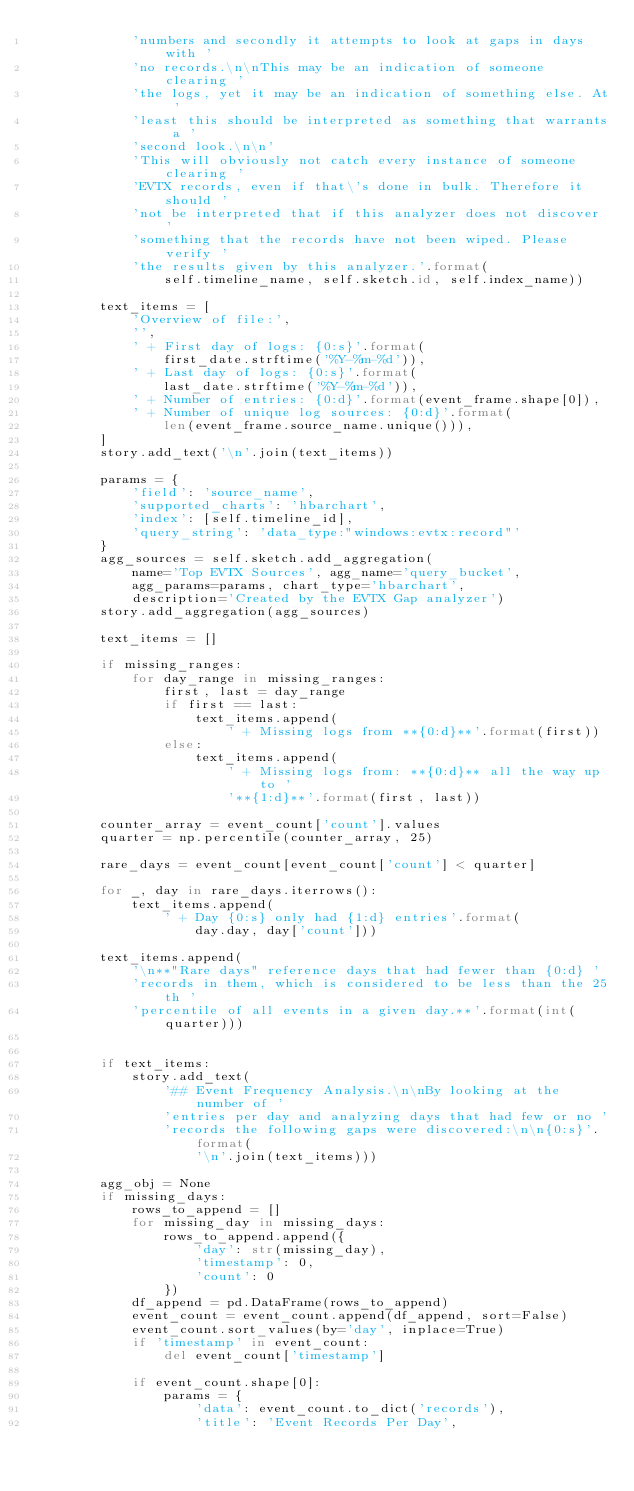Convert code to text. <code><loc_0><loc_0><loc_500><loc_500><_Python_>            'numbers and secondly it attempts to look at gaps in days with '
            'no records.\n\nThis may be an indication of someone clearing '
            'the logs, yet it may be an indication of something else. At '
            'least this should be interpreted as something that warrants a '
            'second look.\n\n'
            'This will obviously not catch every instance of someone clearing '
            'EVTX records, even if that\'s done in bulk. Therefore it should '
            'not be interpreted that if this analyzer does not discover '
            'something that the records have not been wiped. Please verify '
            'the results given by this analyzer.'.format(
                self.timeline_name, self.sketch.id, self.index_name))

        text_items = [
            'Overview of file:',
            '',
            ' + First day of logs: {0:s}'.format(
                first_date.strftime('%Y-%m-%d')),
            ' + Last day of logs: {0:s}'.format(
                last_date.strftime('%Y-%m-%d')),
            ' + Number of entries: {0:d}'.format(event_frame.shape[0]),
            ' + Number of unique log sources: {0:d}'.format(
                len(event_frame.source_name.unique())),
        ]
        story.add_text('\n'.join(text_items))

        params = {
            'field': 'source_name',
            'supported_charts': 'hbarchart',
            'index': [self.timeline_id],
            'query_string': 'data_type:"windows:evtx:record"'
        }
        agg_sources = self.sketch.add_aggregation(
            name='Top EVTX Sources', agg_name='query_bucket',
            agg_params=params, chart_type='hbarchart',
            description='Created by the EVTX Gap analyzer')
        story.add_aggregation(agg_sources)

        text_items = []

        if missing_ranges:
            for day_range in missing_ranges:
                first, last = day_range
                if first == last:
                    text_items.append(
                        ' + Missing logs from **{0:d}**'.format(first))
                else:
                    text_items.append(
                        ' + Missing logs from: **{0:d}** all the way up to '
                        '**{1:d}**'.format(first, last))

        counter_array = event_count['count'].values
        quarter = np.percentile(counter_array, 25)

        rare_days = event_count[event_count['count'] < quarter]

        for _, day in rare_days.iterrows():
            text_items.append(
                ' + Day {0:s} only had {1:d} entries'.format(
                    day.day, day['count']))

        text_items.append(
            '\n**"Rare days" reference days that had fewer than {0:d} '
            'records in them, which is considered to be less than the 25th '
            'percentile of all events in a given day.**'.format(int(quarter)))


        if text_items:
            story.add_text(
                '## Event Frequency Analysis.\n\nBy looking at the number of '
                'entries per day and analyzing days that had few or no '
                'records the following gaps were discovered:\n\n{0:s}'.format(
                    '\n'.join(text_items)))

        agg_obj = None
        if missing_days:
            rows_to_append = []
            for missing_day in missing_days:
                rows_to_append.append({
                    'day': str(missing_day),
                    'timestamp': 0,
                    'count': 0
                })
            df_append = pd.DataFrame(rows_to_append)
            event_count = event_count.append(df_append, sort=False)
            event_count.sort_values(by='day', inplace=True)
            if 'timestamp' in event_count:
                del event_count['timestamp']

            if event_count.shape[0]:
                params = {
                    'data': event_count.to_dict('records'),
                    'title': 'Event Records Per Day',</code> 